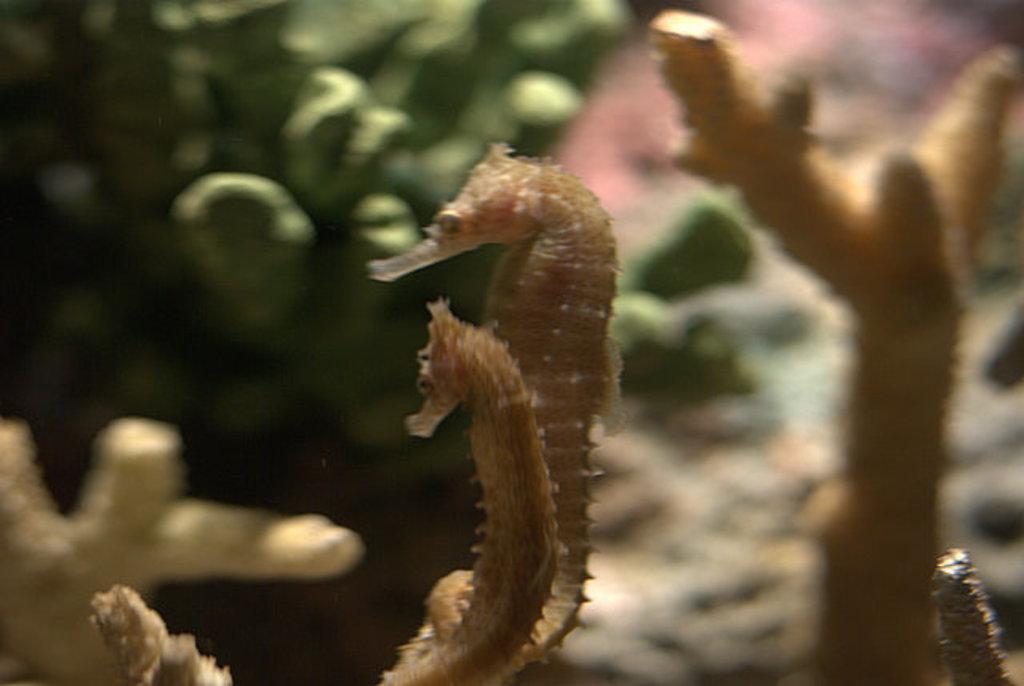How would you summarize this image in a sentence or two? In this picture we can see northern seahorses and plants. 